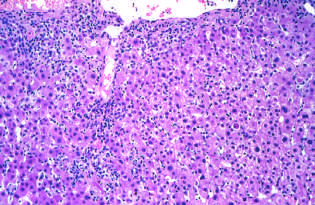s acute viral hepatitis characterize by a predominantly lymphocytic infiltrate?
Answer the question using a single word or phrase. Yes 